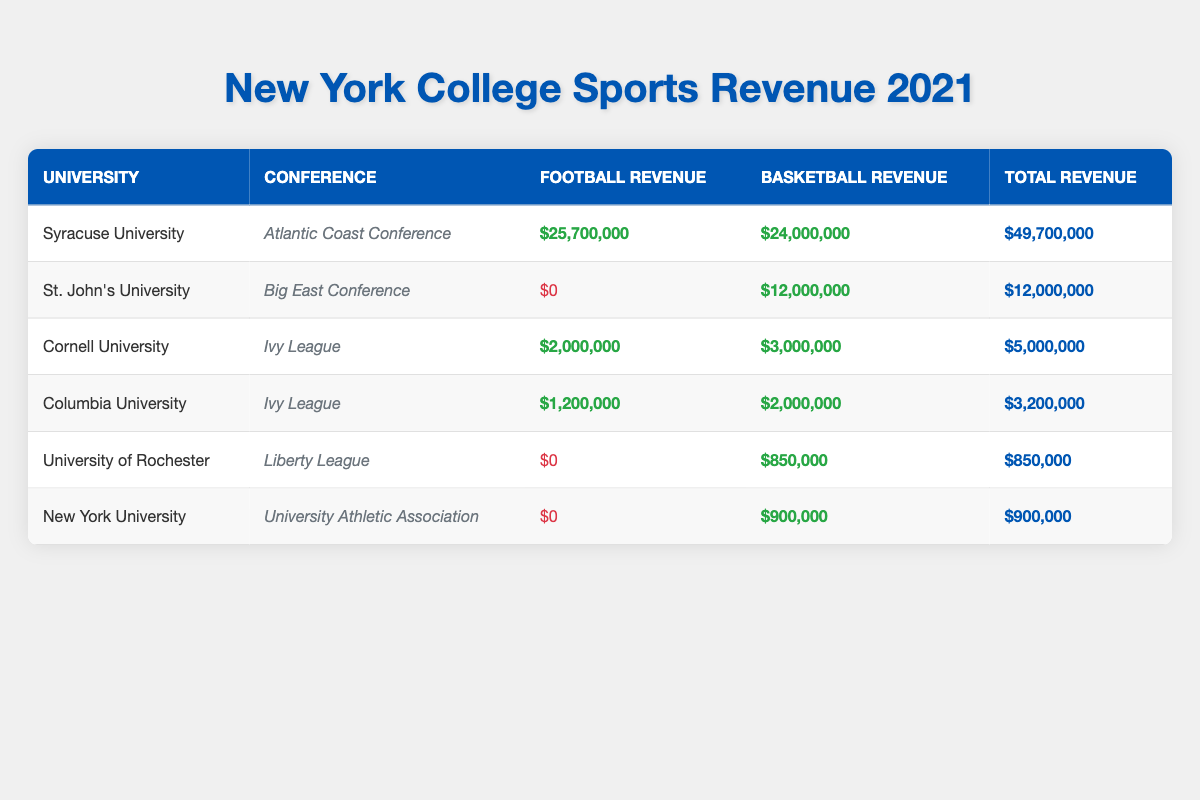What university generated the highest total revenue in 2021? From the table, we can clearly see that Syracuse University has the highest total revenue at $49,700,000.
Answer: Syracuse University Which university generated no football revenue? By reviewing the football revenue figures in the table, it is evident that St. John's University, University of Rochester, New York University, and Rider University all show $0 in football revenue.
Answer: St. John's University, University of Rochester, New York University, and Rider University What is the total football revenue generated by Ivy League universities? Cornell University has $2,000,000 and Columbia University has $1,200,000 in football revenue. Adding these amounts together: $2,000,000 + $1,200,000 = $3,200,000.
Answer: $3,200,000 Does the University at Buffalo generate more revenue from basketball or football? The table shows University at Buffalo has $2,500,000 from basketball and $1,050,000 from football. Since $2,500,000 > $1,050,000, the answer is basketball revenue is greater.
Answer: Yes, basketball revenue is greater What percentage of total revenue does Syracuse University contribute to the combined total revenue of all universities listed? First, sum the total revenues of all universities. The sum is $49,700,000 (Syracuse) + $12,000,000 (St. John’s) + $5,000,000 (Cornell) + $3,200,000 (Columbia) + $850,000 (Rochester) + $900,000 (NYU) = $71,650,000. Syracuse's contribution percentage is ($49,700,000 / $71,650,000) * 100 ≈ 69.3%.
Answer: Approximately 69.3% What is the total revenue for all universities in the Mid-American Conference? The only university listed in the Mid-American Conference is the University at Buffalo, which has a total revenue of $3,550,000. There are no other universities in that conference, so the total remains the same.
Answer: $3,550,000 Which conference has the highest individual football revenue among the universities listed? By looking at the football revenues, Syracuse University (Atlantic Coast Conference) has the highest at $25,700,000, compared to others in various conferences.
Answer: Atlantic Coast Conference Is there any university that earned more from basketball than from football, and if so, which is it? St. John's University earned $12,000,000 from basketball and $0 from football. Also, University of Rochester earned $850,000 from basketball while having $0 from football. Both cases indicate basketball revenue is more.
Answer: Yes, St. John's University and University of Rochester How much greater is the total basketball revenue compared to the total football revenue across all listed universities? Calculate total basketball revenue: $24,000,000 (Syracuse) + $12,000,000 (St. John's) + $3,000,000 (Cornell) + $2,000,000 (Columbia) + $850,000 (Rochester) + $900,000 (NYU) = $42,750,000. Total football revenue is $25,700,000 (Syracuse) + $0 (St. John's) + $2,000,000 (Cornell) + $1,200,000 (Columbia) + $0 (Rochester) + $0 (NYU) = $28,900,000. The difference is $42,750,000 - $28,900,000 = $13,850,000.
Answer: $13,850,000 